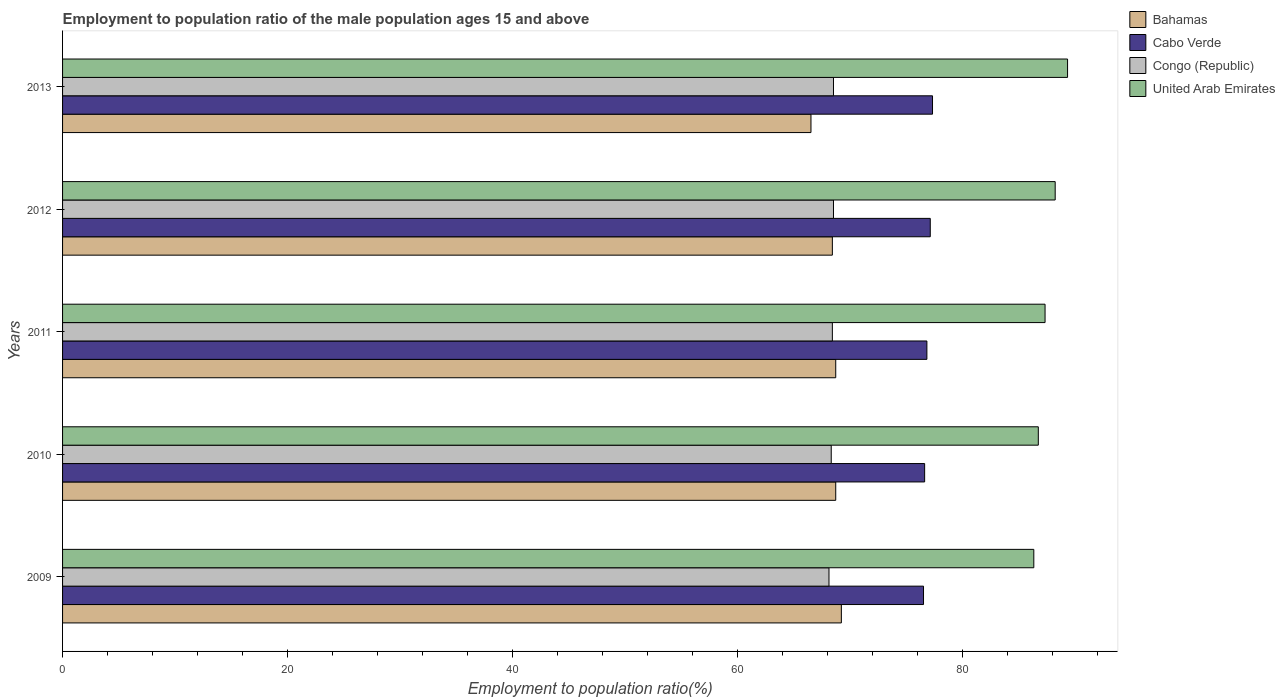How many groups of bars are there?
Your answer should be very brief. 5. Are the number of bars on each tick of the Y-axis equal?
Give a very brief answer. Yes. In how many cases, is the number of bars for a given year not equal to the number of legend labels?
Your answer should be very brief. 0. What is the employment to population ratio in Congo (Republic) in 2013?
Your answer should be compact. 68.5. Across all years, what is the maximum employment to population ratio in Congo (Republic)?
Your answer should be very brief. 68.5. Across all years, what is the minimum employment to population ratio in Bahamas?
Ensure brevity in your answer.  66.5. In which year was the employment to population ratio in United Arab Emirates maximum?
Your answer should be compact. 2013. In which year was the employment to population ratio in United Arab Emirates minimum?
Offer a very short reply. 2009. What is the total employment to population ratio in Cabo Verde in the graph?
Your answer should be compact. 384.3. What is the difference between the employment to population ratio in Bahamas in 2011 and the employment to population ratio in United Arab Emirates in 2012?
Your response must be concise. -19.5. What is the average employment to population ratio in Congo (Republic) per year?
Your answer should be compact. 68.36. In the year 2009, what is the difference between the employment to population ratio in Bahamas and employment to population ratio in Congo (Republic)?
Keep it short and to the point. 1.1. In how many years, is the employment to population ratio in Cabo Verde greater than 88 %?
Your answer should be compact. 0. What is the ratio of the employment to population ratio in Cabo Verde in 2009 to that in 2011?
Your answer should be very brief. 1. Is the employment to population ratio in Cabo Verde in 2009 less than that in 2013?
Your response must be concise. Yes. Is the difference between the employment to population ratio in Bahamas in 2010 and 2011 greater than the difference between the employment to population ratio in Congo (Republic) in 2010 and 2011?
Offer a terse response. Yes. What is the difference between the highest and the second highest employment to population ratio in Congo (Republic)?
Ensure brevity in your answer.  0. What does the 1st bar from the top in 2011 represents?
Your answer should be very brief. United Arab Emirates. What does the 3rd bar from the bottom in 2009 represents?
Give a very brief answer. Congo (Republic). Is it the case that in every year, the sum of the employment to population ratio in Bahamas and employment to population ratio in Congo (Republic) is greater than the employment to population ratio in Cabo Verde?
Offer a very short reply. Yes. What is the difference between two consecutive major ticks on the X-axis?
Offer a terse response. 20. Are the values on the major ticks of X-axis written in scientific E-notation?
Provide a short and direct response. No. Does the graph contain any zero values?
Your answer should be very brief. No. What is the title of the graph?
Your answer should be compact. Employment to population ratio of the male population ages 15 and above. Does "Vietnam" appear as one of the legend labels in the graph?
Your answer should be compact. No. What is the label or title of the X-axis?
Give a very brief answer. Employment to population ratio(%). What is the label or title of the Y-axis?
Provide a short and direct response. Years. What is the Employment to population ratio(%) in Bahamas in 2009?
Ensure brevity in your answer.  69.2. What is the Employment to population ratio(%) in Cabo Verde in 2009?
Provide a succinct answer. 76.5. What is the Employment to population ratio(%) of Congo (Republic) in 2009?
Provide a succinct answer. 68.1. What is the Employment to population ratio(%) in United Arab Emirates in 2009?
Your answer should be compact. 86.3. What is the Employment to population ratio(%) in Bahamas in 2010?
Offer a terse response. 68.7. What is the Employment to population ratio(%) in Cabo Verde in 2010?
Your response must be concise. 76.6. What is the Employment to population ratio(%) in Congo (Republic) in 2010?
Your answer should be very brief. 68.3. What is the Employment to population ratio(%) of United Arab Emirates in 2010?
Give a very brief answer. 86.7. What is the Employment to population ratio(%) in Bahamas in 2011?
Make the answer very short. 68.7. What is the Employment to population ratio(%) in Cabo Verde in 2011?
Ensure brevity in your answer.  76.8. What is the Employment to population ratio(%) in Congo (Republic) in 2011?
Give a very brief answer. 68.4. What is the Employment to population ratio(%) of United Arab Emirates in 2011?
Keep it short and to the point. 87.3. What is the Employment to population ratio(%) in Bahamas in 2012?
Give a very brief answer. 68.4. What is the Employment to population ratio(%) in Cabo Verde in 2012?
Give a very brief answer. 77.1. What is the Employment to population ratio(%) in Congo (Republic) in 2012?
Your response must be concise. 68.5. What is the Employment to population ratio(%) of United Arab Emirates in 2012?
Ensure brevity in your answer.  88.2. What is the Employment to population ratio(%) in Bahamas in 2013?
Your answer should be compact. 66.5. What is the Employment to population ratio(%) of Cabo Verde in 2013?
Give a very brief answer. 77.3. What is the Employment to population ratio(%) of Congo (Republic) in 2013?
Ensure brevity in your answer.  68.5. What is the Employment to population ratio(%) of United Arab Emirates in 2013?
Give a very brief answer. 89.3. Across all years, what is the maximum Employment to population ratio(%) in Bahamas?
Make the answer very short. 69.2. Across all years, what is the maximum Employment to population ratio(%) in Cabo Verde?
Your response must be concise. 77.3. Across all years, what is the maximum Employment to population ratio(%) in Congo (Republic)?
Your response must be concise. 68.5. Across all years, what is the maximum Employment to population ratio(%) in United Arab Emirates?
Offer a terse response. 89.3. Across all years, what is the minimum Employment to population ratio(%) of Bahamas?
Make the answer very short. 66.5. Across all years, what is the minimum Employment to population ratio(%) of Cabo Verde?
Make the answer very short. 76.5. Across all years, what is the minimum Employment to population ratio(%) of Congo (Republic)?
Keep it short and to the point. 68.1. Across all years, what is the minimum Employment to population ratio(%) in United Arab Emirates?
Ensure brevity in your answer.  86.3. What is the total Employment to population ratio(%) of Bahamas in the graph?
Provide a short and direct response. 341.5. What is the total Employment to population ratio(%) in Cabo Verde in the graph?
Give a very brief answer. 384.3. What is the total Employment to population ratio(%) of Congo (Republic) in the graph?
Provide a succinct answer. 341.8. What is the total Employment to population ratio(%) of United Arab Emirates in the graph?
Ensure brevity in your answer.  437.8. What is the difference between the Employment to population ratio(%) of Bahamas in 2009 and that in 2010?
Your answer should be compact. 0.5. What is the difference between the Employment to population ratio(%) in United Arab Emirates in 2009 and that in 2010?
Provide a short and direct response. -0.4. What is the difference between the Employment to population ratio(%) of Cabo Verde in 2009 and that in 2011?
Give a very brief answer. -0.3. What is the difference between the Employment to population ratio(%) in Cabo Verde in 2009 and that in 2012?
Give a very brief answer. -0.6. What is the difference between the Employment to population ratio(%) in Congo (Republic) in 2009 and that in 2012?
Offer a terse response. -0.4. What is the difference between the Employment to population ratio(%) in United Arab Emirates in 2009 and that in 2012?
Provide a short and direct response. -1.9. What is the difference between the Employment to population ratio(%) of Bahamas in 2009 and that in 2013?
Your answer should be very brief. 2.7. What is the difference between the Employment to population ratio(%) in United Arab Emirates in 2009 and that in 2013?
Make the answer very short. -3. What is the difference between the Employment to population ratio(%) in Cabo Verde in 2010 and that in 2011?
Make the answer very short. -0.2. What is the difference between the Employment to population ratio(%) in Congo (Republic) in 2010 and that in 2011?
Keep it short and to the point. -0.1. What is the difference between the Employment to population ratio(%) of Cabo Verde in 2010 and that in 2012?
Give a very brief answer. -0.5. What is the difference between the Employment to population ratio(%) of Congo (Republic) in 2010 and that in 2012?
Offer a terse response. -0.2. What is the difference between the Employment to population ratio(%) in Congo (Republic) in 2010 and that in 2013?
Offer a terse response. -0.2. What is the difference between the Employment to population ratio(%) of United Arab Emirates in 2010 and that in 2013?
Ensure brevity in your answer.  -2.6. What is the difference between the Employment to population ratio(%) of Cabo Verde in 2011 and that in 2012?
Ensure brevity in your answer.  -0.3. What is the difference between the Employment to population ratio(%) of United Arab Emirates in 2011 and that in 2012?
Give a very brief answer. -0.9. What is the difference between the Employment to population ratio(%) in Cabo Verde in 2011 and that in 2013?
Your answer should be compact. -0.5. What is the difference between the Employment to population ratio(%) in Bahamas in 2009 and the Employment to population ratio(%) in Cabo Verde in 2010?
Keep it short and to the point. -7.4. What is the difference between the Employment to population ratio(%) of Bahamas in 2009 and the Employment to population ratio(%) of Congo (Republic) in 2010?
Offer a very short reply. 0.9. What is the difference between the Employment to population ratio(%) in Bahamas in 2009 and the Employment to population ratio(%) in United Arab Emirates in 2010?
Provide a succinct answer. -17.5. What is the difference between the Employment to population ratio(%) in Cabo Verde in 2009 and the Employment to population ratio(%) in Congo (Republic) in 2010?
Provide a short and direct response. 8.2. What is the difference between the Employment to population ratio(%) in Congo (Republic) in 2009 and the Employment to population ratio(%) in United Arab Emirates in 2010?
Offer a terse response. -18.6. What is the difference between the Employment to population ratio(%) in Bahamas in 2009 and the Employment to population ratio(%) in United Arab Emirates in 2011?
Offer a very short reply. -18.1. What is the difference between the Employment to population ratio(%) in Cabo Verde in 2009 and the Employment to population ratio(%) in United Arab Emirates in 2011?
Offer a terse response. -10.8. What is the difference between the Employment to population ratio(%) of Congo (Republic) in 2009 and the Employment to population ratio(%) of United Arab Emirates in 2011?
Ensure brevity in your answer.  -19.2. What is the difference between the Employment to population ratio(%) in Cabo Verde in 2009 and the Employment to population ratio(%) in United Arab Emirates in 2012?
Make the answer very short. -11.7. What is the difference between the Employment to population ratio(%) of Congo (Republic) in 2009 and the Employment to population ratio(%) of United Arab Emirates in 2012?
Provide a short and direct response. -20.1. What is the difference between the Employment to population ratio(%) of Bahamas in 2009 and the Employment to population ratio(%) of Congo (Republic) in 2013?
Offer a terse response. 0.7. What is the difference between the Employment to population ratio(%) of Bahamas in 2009 and the Employment to population ratio(%) of United Arab Emirates in 2013?
Give a very brief answer. -20.1. What is the difference between the Employment to population ratio(%) of Cabo Verde in 2009 and the Employment to population ratio(%) of Congo (Republic) in 2013?
Offer a terse response. 8. What is the difference between the Employment to population ratio(%) in Cabo Verde in 2009 and the Employment to population ratio(%) in United Arab Emirates in 2013?
Keep it short and to the point. -12.8. What is the difference between the Employment to population ratio(%) of Congo (Republic) in 2009 and the Employment to population ratio(%) of United Arab Emirates in 2013?
Your answer should be very brief. -21.2. What is the difference between the Employment to population ratio(%) in Bahamas in 2010 and the Employment to population ratio(%) in Cabo Verde in 2011?
Provide a succinct answer. -8.1. What is the difference between the Employment to population ratio(%) of Bahamas in 2010 and the Employment to population ratio(%) of Congo (Republic) in 2011?
Make the answer very short. 0.3. What is the difference between the Employment to population ratio(%) in Bahamas in 2010 and the Employment to population ratio(%) in United Arab Emirates in 2011?
Provide a succinct answer. -18.6. What is the difference between the Employment to population ratio(%) in Cabo Verde in 2010 and the Employment to population ratio(%) in Congo (Republic) in 2011?
Your answer should be very brief. 8.2. What is the difference between the Employment to population ratio(%) of Cabo Verde in 2010 and the Employment to population ratio(%) of United Arab Emirates in 2011?
Your response must be concise. -10.7. What is the difference between the Employment to population ratio(%) in Congo (Republic) in 2010 and the Employment to population ratio(%) in United Arab Emirates in 2011?
Give a very brief answer. -19. What is the difference between the Employment to population ratio(%) in Bahamas in 2010 and the Employment to population ratio(%) in Cabo Verde in 2012?
Offer a very short reply. -8.4. What is the difference between the Employment to population ratio(%) of Bahamas in 2010 and the Employment to population ratio(%) of United Arab Emirates in 2012?
Give a very brief answer. -19.5. What is the difference between the Employment to population ratio(%) of Congo (Republic) in 2010 and the Employment to population ratio(%) of United Arab Emirates in 2012?
Offer a terse response. -19.9. What is the difference between the Employment to population ratio(%) in Bahamas in 2010 and the Employment to population ratio(%) in United Arab Emirates in 2013?
Provide a short and direct response. -20.6. What is the difference between the Employment to population ratio(%) in Cabo Verde in 2010 and the Employment to population ratio(%) in United Arab Emirates in 2013?
Make the answer very short. -12.7. What is the difference between the Employment to population ratio(%) of Congo (Republic) in 2010 and the Employment to population ratio(%) of United Arab Emirates in 2013?
Your response must be concise. -21. What is the difference between the Employment to population ratio(%) of Bahamas in 2011 and the Employment to population ratio(%) of Cabo Verde in 2012?
Provide a succinct answer. -8.4. What is the difference between the Employment to population ratio(%) of Bahamas in 2011 and the Employment to population ratio(%) of Congo (Republic) in 2012?
Your answer should be very brief. 0.2. What is the difference between the Employment to population ratio(%) of Bahamas in 2011 and the Employment to population ratio(%) of United Arab Emirates in 2012?
Make the answer very short. -19.5. What is the difference between the Employment to population ratio(%) in Cabo Verde in 2011 and the Employment to population ratio(%) in United Arab Emirates in 2012?
Ensure brevity in your answer.  -11.4. What is the difference between the Employment to population ratio(%) in Congo (Republic) in 2011 and the Employment to population ratio(%) in United Arab Emirates in 2012?
Provide a succinct answer. -19.8. What is the difference between the Employment to population ratio(%) in Bahamas in 2011 and the Employment to population ratio(%) in Cabo Verde in 2013?
Provide a succinct answer. -8.6. What is the difference between the Employment to population ratio(%) of Bahamas in 2011 and the Employment to population ratio(%) of Congo (Republic) in 2013?
Your answer should be compact. 0.2. What is the difference between the Employment to population ratio(%) of Bahamas in 2011 and the Employment to population ratio(%) of United Arab Emirates in 2013?
Make the answer very short. -20.6. What is the difference between the Employment to population ratio(%) of Cabo Verde in 2011 and the Employment to population ratio(%) of United Arab Emirates in 2013?
Ensure brevity in your answer.  -12.5. What is the difference between the Employment to population ratio(%) in Congo (Republic) in 2011 and the Employment to population ratio(%) in United Arab Emirates in 2013?
Your answer should be very brief. -20.9. What is the difference between the Employment to population ratio(%) in Bahamas in 2012 and the Employment to population ratio(%) in Congo (Republic) in 2013?
Offer a very short reply. -0.1. What is the difference between the Employment to population ratio(%) of Bahamas in 2012 and the Employment to population ratio(%) of United Arab Emirates in 2013?
Make the answer very short. -20.9. What is the difference between the Employment to population ratio(%) in Cabo Verde in 2012 and the Employment to population ratio(%) in Congo (Republic) in 2013?
Offer a terse response. 8.6. What is the difference between the Employment to population ratio(%) in Cabo Verde in 2012 and the Employment to population ratio(%) in United Arab Emirates in 2013?
Your answer should be compact. -12.2. What is the difference between the Employment to population ratio(%) of Congo (Republic) in 2012 and the Employment to population ratio(%) of United Arab Emirates in 2013?
Your answer should be compact. -20.8. What is the average Employment to population ratio(%) in Bahamas per year?
Offer a very short reply. 68.3. What is the average Employment to population ratio(%) in Cabo Verde per year?
Ensure brevity in your answer.  76.86. What is the average Employment to population ratio(%) of Congo (Republic) per year?
Keep it short and to the point. 68.36. What is the average Employment to population ratio(%) in United Arab Emirates per year?
Offer a terse response. 87.56. In the year 2009, what is the difference between the Employment to population ratio(%) of Bahamas and Employment to population ratio(%) of Cabo Verde?
Make the answer very short. -7.3. In the year 2009, what is the difference between the Employment to population ratio(%) of Bahamas and Employment to population ratio(%) of Congo (Republic)?
Provide a short and direct response. 1.1. In the year 2009, what is the difference between the Employment to population ratio(%) of Bahamas and Employment to population ratio(%) of United Arab Emirates?
Provide a succinct answer. -17.1. In the year 2009, what is the difference between the Employment to population ratio(%) in Cabo Verde and Employment to population ratio(%) in Congo (Republic)?
Offer a terse response. 8.4. In the year 2009, what is the difference between the Employment to population ratio(%) of Cabo Verde and Employment to population ratio(%) of United Arab Emirates?
Provide a short and direct response. -9.8. In the year 2009, what is the difference between the Employment to population ratio(%) of Congo (Republic) and Employment to population ratio(%) of United Arab Emirates?
Your answer should be compact. -18.2. In the year 2010, what is the difference between the Employment to population ratio(%) in Bahamas and Employment to population ratio(%) in Cabo Verde?
Give a very brief answer. -7.9. In the year 2010, what is the difference between the Employment to population ratio(%) of Bahamas and Employment to population ratio(%) of United Arab Emirates?
Your answer should be compact. -18. In the year 2010, what is the difference between the Employment to population ratio(%) in Cabo Verde and Employment to population ratio(%) in United Arab Emirates?
Offer a terse response. -10.1. In the year 2010, what is the difference between the Employment to population ratio(%) in Congo (Republic) and Employment to population ratio(%) in United Arab Emirates?
Ensure brevity in your answer.  -18.4. In the year 2011, what is the difference between the Employment to population ratio(%) of Bahamas and Employment to population ratio(%) of United Arab Emirates?
Your answer should be compact. -18.6. In the year 2011, what is the difference between the Employment to population ratio(%) of Congo (Republic) and Employment to population ratio(%) of United Arab Emirates?
Provide a succinct answer. -18.9. In the year 2012, what is the difference between the Employment to population ratio(%) in Bahamas and Employment to population ratio(%) in United Arab Emirates?
Ensure brevity in your answer.  -19.8. In the year 2012, what is the difference between the Employment to population ratio(%) in Cabo Verde and Employment to population ratio(%) in United Arab Emirates?
Your answer should be compact. -11.1. In the year 2012, what is the difference between the Employment to population ratio(%) of Congo (Republic) and Employment to population ratio(%) of United Arab Emirates?
Make the answer very short. -19.7. In the year 2013, what is the difference between the Employment to population ratio(%) of Bahamas and Employment to population ratio(%) of United Arab Emirates?
Your response must be concise. -22.8. In the year 2013, what is the difference between the Employment to population ratio(%) of Cabo Verde and Employment to population ratio(%) of United Arab Emirates?
Provide a short and direct response. -12. In the year 2013, what is the difference between the Employment to population ratio(%) in Congo (Republic) and Employment to population ratio(%) in United Arab Emirates?
Make the answer very short. -20.8. What is the ratio of the Employment to population ratio(%) of Bahamas in 2009 to that in 2010?
Keep it short and to the point. 1.01. What is the ratio of the Employment to population ratio(%) of United Arab Emirates in 2009 to that in 2010?
Provide a short and direct response. 1. What is the ratio of the Employment to population ratio(%) of Bahamas in 2009 to that in 2011?
Provide a short and direct response. 1.01. What is the ratio of the Employment to population ratio(%) of United Arab Emirates in 2009 to that in 2011?
Keep it short and to the point. 0.99. What is the ratio of the Employment to population ratio(%) of Bahamas in 2009 to that in 2012?
Your answer should be compact. 1.01. What is the ratio of the Employment to population ratio(%) in Cabo Verde in 2009 to that in 2012?
Your answer should be very brief. 0.99. What is the ratio of the Employment to population ratio(%) in Congo (Republic) in 2009 to that in 2012?
Offer a very short reply. 0.99. What is the ratio of the Employment to population ratio(%) of United Arab Emirates in 2009 to that in 2012?
Give a very brief answer. 0.98. What is the ratio of the Employment to population ratio(%) of Bahamas in 2009 to that in 2013?
Keep it short and to the point. 1.04. What is the ratio of the Employment to population ratio(%) of United Arab Emirates in 2009 to that in 2013?
Make the answer very short. 0.97. What is the ratio of the Employment to population ratio(%) of United Arab Emirates in 2010 to that in 2011?
Keep it short and to the point. 0.99. What is the ratio of the Employment to population ratio(%) of Bahamas in 2010 to that in 2012?
Provide a succinct answer. 1. What is the ratio of the Employment to population ratio(%) of Cabo Verde in 2010 to that in 2012?
Ensure brevity in your answer.  0.99. What is the ratio of the Employment to population ratio(%) in United Arab Emirates in 2010 to that in 2012?
Offer a terse response. 0.98. What is the ratio of the Employment to population ratio(%) of Bahamas in 2010 to that in 2013?
Ensure brevity in your answer.  1.03. What is the ratio of the Employment to population ratio(%) in Cabo Verde in 2010 to that in 2013?
Ensure brevity in your answer.  0.99. What is the ratio of the Employment to population ratio(%) of Congo (Republic) in 2010 to that in 2013?
Offer a terse response. 1. What is the ratio of the Employment to population ratio(%) of United Arab Emirates in 2010 to that in 2013?
Offer a terse response. 0.97. What is the ratio of the Employment to population ratio(%) of United Arab Emirates in 2011 to that in 2012?
Ensure brevity in your answer.  0.99. What is the ratio of the Employment to population ratio(%) in Bahamas in 2011 to that in 2013?
Offer a terse response. 1.03. What is the ratio of the Employment to population ratio(%) of Cabo Verde in 2011 to that in 2013?
Provide a succinct answer. 0.99. What is the ratio of the Employment to population ratio(%) of Congo (Republic) in 2011 to that in 2013?
Your answer should be compact. 1. What is the ratio of the Employment to population ratio(%) of United Arab Emirates in 2011 to that in 2013?
Give a very brief answer. 0.98. What is the ratio of the Employment to population ratio(%) of Bahamas in 2012 to that in 2013?
Your response must be concise. 1.03. What is the ratio of the Employment to population ratio(%) of Cabo Verde in 2012 to that in 2013?
Provide a succinct answer. 1. What is the ratio of the Employment to population ratio(%) in United Arab Emirates in 2012 to that in 2013?
Offer a terse response. 0.99. What is the difference between the highest and the second highest Employment to population ratio(%) in Bahamas?
Provide a succinct answer. 0.5. What is the difference between the highest and the second highest Employment to population ratio(%) in United Arab Emirates?
Make the answer very short. 1.1. What is the difference between the highest and the lowest Employment to population ratio(%) in Bahamas?
Make the answer very short. 2.7. What is the difference between the highest and the lowest Employment to population ratio(%) of United Arab Emirates?
Your response must be concise. 3. 